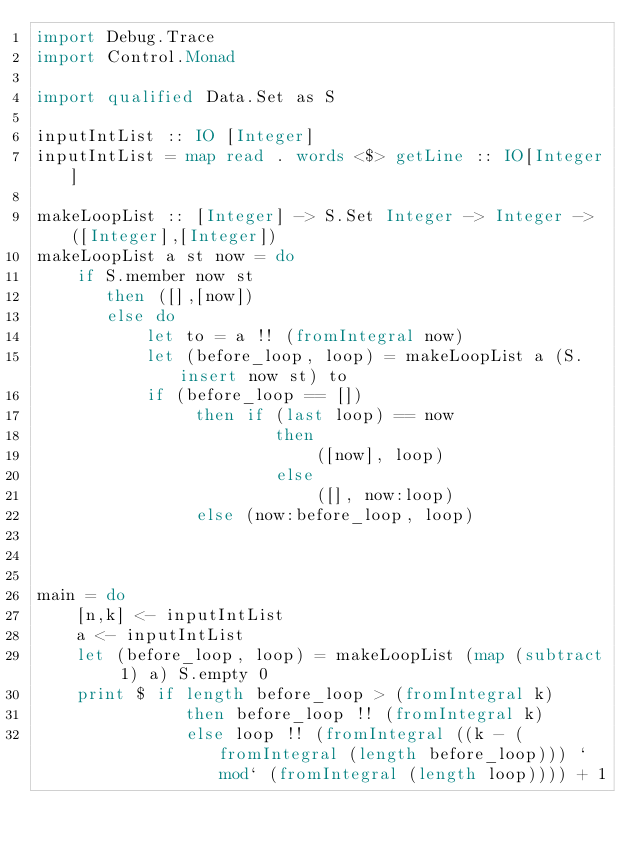Convert code to text. <code><loc_0><loc_0><loc_500><loc_500><_Haskell_>import Debug.Trace
import Control.Monad

import qualified Data.Set as S

inputIntList :: IO [Integer]
inputIntList = map read . words <$> getLine :: IO[Integer]

makeLoopList :: [Integer] -> S.Set Integer -> Integer -> ([Integer],[Integer])
makeLoopList a st now = do
    if S.member now st
       then ([],[now])
       else do
           let to = a !! (fromIntegral now)
           let (before_loop, loop) = makeLoopList a (S.insert now st) to
           if (before_loop == [])
                then if (last loop) == now
                        then 
                            ([now], loop)
                        else 
                            ([], now:loop)
                else (now:before_loop, loop) 

    

main = do
    [n,k] <- inputIntList
    a <- inputIntList
    let (before_loop, loop) = makeLoopList (map (subtract 1) a) S.empty 0
    print $ if length before_loop > (fromIntegral k)
               then before_loop !! (fromIntegral k)
               else loop !! (fromIntegral ((k - (fromIntegral (length before_loop))) `mod` (fromIntegral (length loop)))) + 1
</code> 